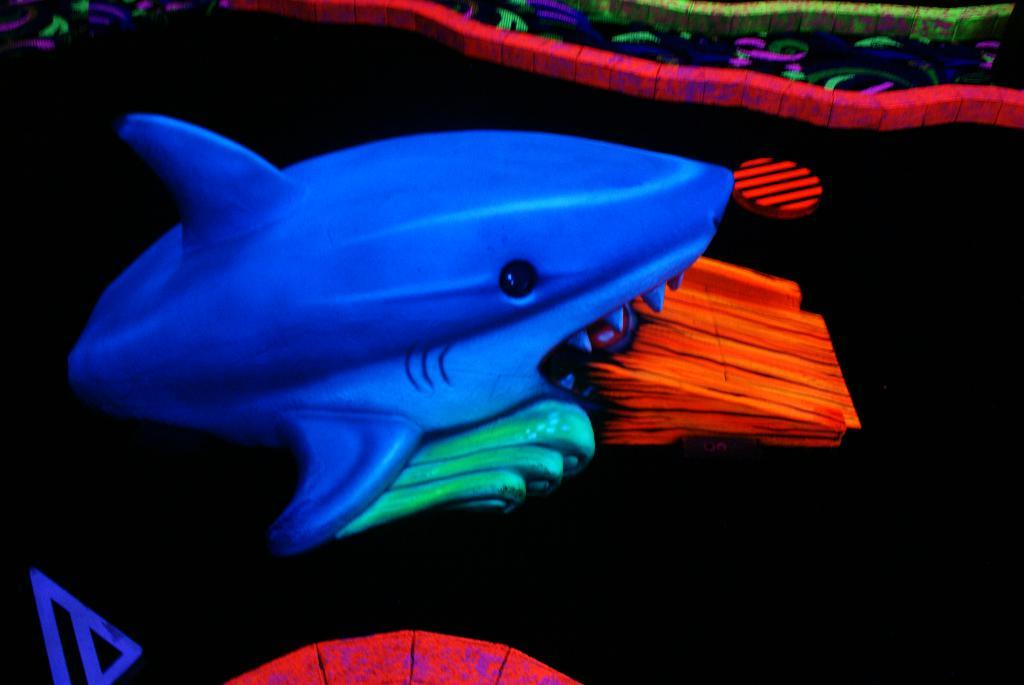What type of toy is present in the image? There is a toy fish in the image. What color is the toy fish? The toy fish is blue in color. What color is the background of the image? The background of the image is black. Can you tell if the image has been altered or edited in any way? Yes, the image appears to be edited. What type of rock is being used as a potato in the image? There is no rock or potato present in the image. What route is the toy fish taking in the image? The toy fish is not taking any route in the image; it is stationary. 